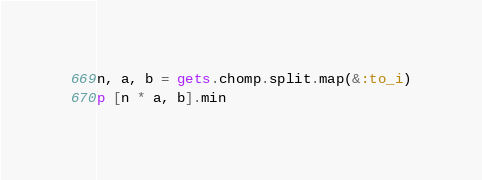<code> <loc_0><loc_0><loc_500><loc_500><_Ruby_>n, a, b = gets.chomp.split.map(&:to_i)
p [n * a, b].min</code> 